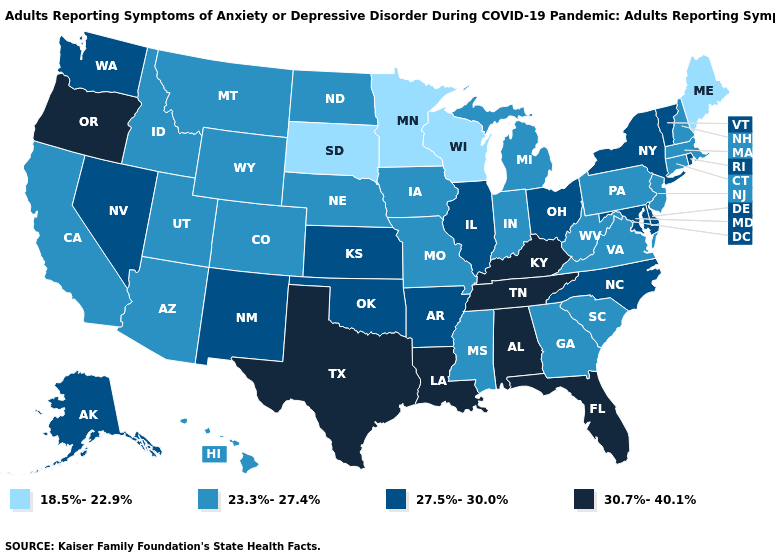What is the value of Georgia?
Short answer required. 23.3%-27.4%. Which states have the highest value in the USA?
Be succinct. Alabama, Florida, Kentucky, Louisiana, Oregon, Tennessee, Texas. Which states have the lowest value in the USA?
Short answer required. Maine, Minnesota, South Dakota, Wisconsin. Which states have the lowest value in the MidWest?
Quick response, please. Minnesota, South Dakota, Wisconsin. What is the value of Arizona?
Be succinct. 23.3%-27.4%. Does Utah have the same value as Minnesota?
Answer briefly. No. What is the value of Michigan?
Answer briefly. 23.3%-27.4%. What is the value of Oklahoma?
Answer briefly. 27.5%-30.0%. How many symbols are there in the legend?
Keep it brief. 4. Which states have the lowest value in the Northeast?
Be succinct. Maine. Does Alaska have the lowest value in the USA?
Give a very brief answer. No. Name the states that have a value in the range 18.5%-22.9%?
Be succinct. Maine, Minnesota, South Dakota, Wisconsin. What is the value of Oregon?
Short answer required. 30.7%-40.1%. What is the value of West Virginia?
Concise answer only. 23.3%-27.4%. Name the states that have a value in the range 30.7%-40.1%?
Keep it brief. Alabama, Florida, Kentucky, Louisiana, Oregon, Tennessee, Texas. 